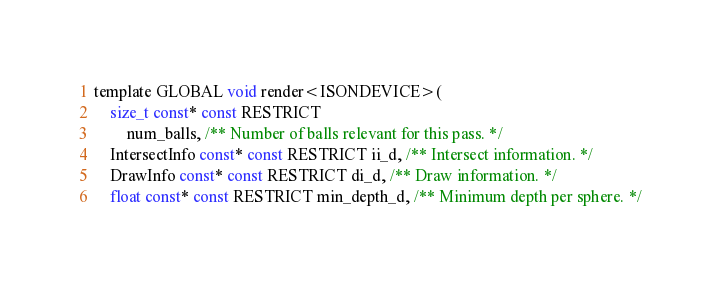Convert code to text. <code><loc_0><loc_0><loc_500><loc_500><_C_>template GLOBAL void render<ISONDEVICE>(
    size_t const* const RESTRICT
        num_balls, /** Number of balls relevant for this pass. */
    IntersectInfo const* const RESTRICT ii_d, /** Intersect information. */
    DrawInfo const* const RESTRICT di_d, /** Draw information. */
    float const* const RESTRICT min_depth_d, /** Minimum depth per sphere. */</code> 